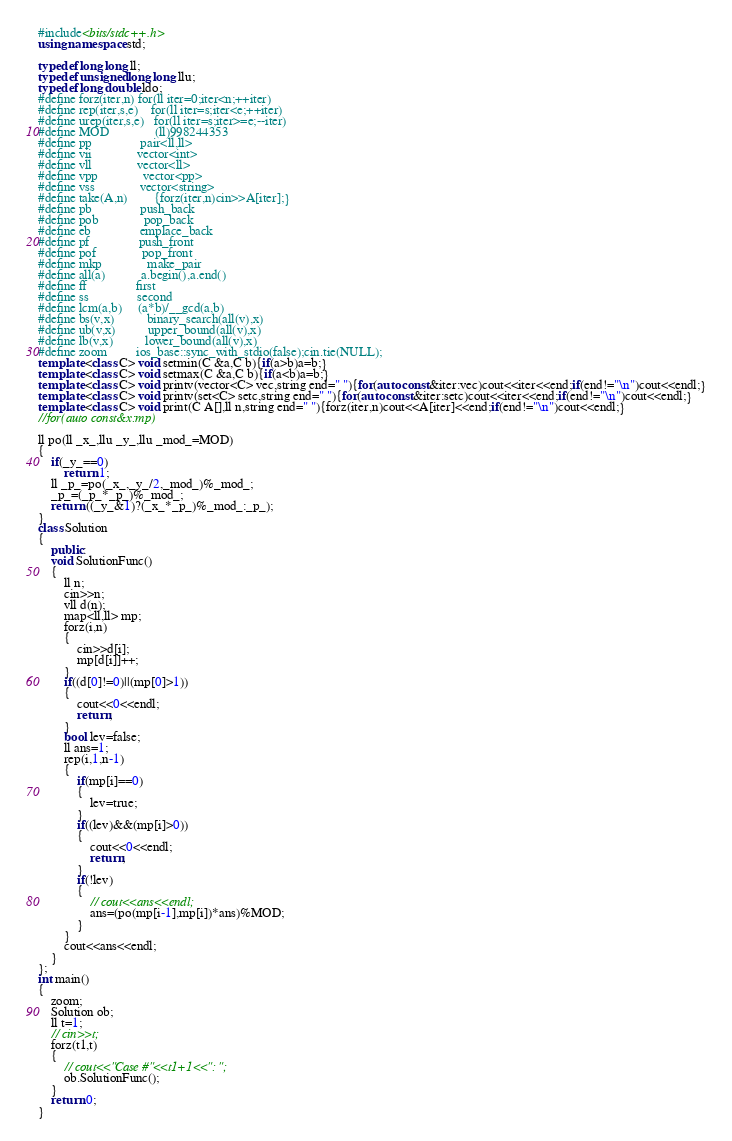Convert code to text. <code><loc_0><loc_0><loc_500><loc_500><_C++_>#include<bits/stdc++.h>
using namespace std;

typedef long long ll;
typedef unsigned long long llu;
typedef long double ldo;
#define forz(iter,n)	for(ll iter=0;iter<n;++iter)
#define rep(iter,s,e)	for(ll iter=s;iter<e;++iter)
#define urep(iter,s,e)	for(ll iter=s;iter>=e;--iter)
#define MOD				(ll)998244353
#define pp				pair<ll,ll>
#define vii				vector<int>
#define vll				vector<ll>
#define vpp				vector<pp>
#define vss				vector<string>
#define take(A,n)		{forz(iter,n)cin>>A[iter];}
#define pb				push_back
#define pob				pop_back
#define eb				emplace_back
#define pf				push_front
#define pof				pop_front
#define mkp				make_pair
#define all(a)			a.begin(),a.end()
#define ff				first
#define ss				second
#define lcm(a,b)		(a*b)/__gcd(a,b)
#define bs(v,x)			binary_search(all(v),x)
#define ub(v,x)			upper_bound(all(v),x)
#define lb(v,x)			lower_bound(all(v),x)
#define zoom			ios_base::sync_with_stdio(false);cin.tie(NULL);
template <class C> void setmin(C &a,C b){if(a>b)a=b;}
template <class C> void setmax(C &a,C b){if(a<b)a=b;}
template <class C> void printv(vector<C> vec,string end=" "){for(auto const&iter:vec)cout<<iter<<end;if(end!="\n")cout<<endl;}
template <class C> void printv(set<C> setc,string end=" "){for(auto const&iter:setc)cout<<iter<<end;if(end!="\n")cout<<endl;}
template <class C> void print(C A[],ll n,string end=" "){forz(iter,n)cout<<A[iter]<<end;if(end!="\n")cout<<endl;}
//for(auto const&x:mp)

ll po(ll _x_,llu _y_,llu _mod_=MOD)
{
	if(_y_==0)
		return 1;
	ll _p_=po(_x_,_y_/2,_mod_)%_mod_;
	_p_=(_p_*_p_)%_mod_;
	return ((_y_&1)?(_x_*_p_)%_mod_:_p_);
}
class Solution
{
	public:
	void SolutionFunc()
	{
		ll n;
		cin>>n;
		vll d(n);
		map<ll,ll> mp;
		forz(i,n)
		{
			cin>>d[i];
			mp[d[i]]++;
		}
		if((d[0]!=0)||(mp[0]>1))
		{
			cout<<0<<endl;
			return;
		}
		bool lev=false;
		ll ans=1;
		rep(i,1,n-1)
		{
			if(mp[i]==0)
			{
				lev=true;
			}
			if((lev)&&(mp[i]>0))
			{
				cout<<0<<endl;
				return;
			}
			if(!lev)
			{
				// cout<<ans<<endl;
				ans=(po(mp[i-1],mp[i])*ans)%MOD;
			}
		}
		cout<<ans<<endl;
	}
};
int main()
{
	zoom;
	Solution ob;
	ll t=1;
	// cin>>t;
	forz(t1,t)
	{
		// cout<<"Case #"<<t1+1<<": ";
		ob.SolutionFunc();
	}
	return 0;
}</code> 